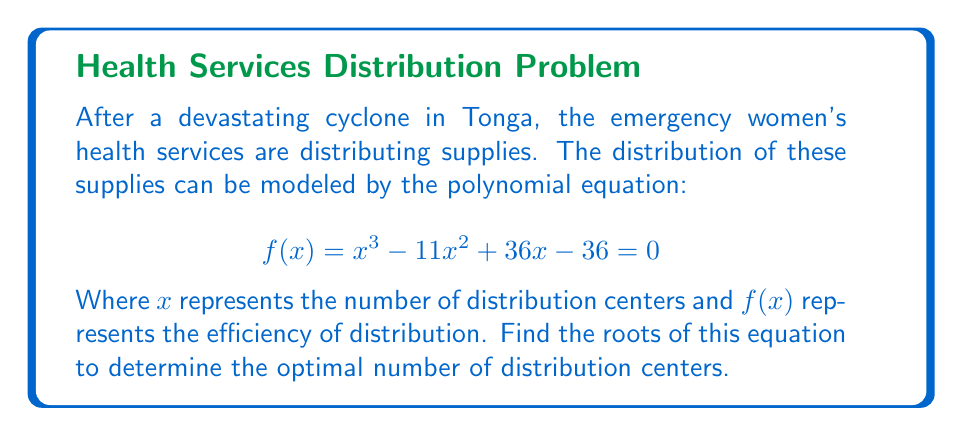Solve this math problem. To find the roots of the polynomial equation, we'll use the factor theorem and synthetic division:

1) First, let's guess a potential root. Since the constant term is -36, potential factors are ±1, ±2, ±3, ±4, ±6, ±9, ±12, ±18, ±36.

2) Let's try x = 3:
   
   $$3^3 - 11(3)^2 + 36(3) - 36 = 27 - 99 + 108 - 36 = 0$$

   So, 3 is a root.

3) Now, let's use synthetic division to factor out (x - 3):

   $$
   \begin{array}{r}
   3 | 1 \quad -11 \quad 36 \quad -36 \\
     | \quad 3 \quad -24 \quad 36 \\
   \hline
     1 \quad -8 \quad 12 \quad 0
   \end{array}
   $$

4) The polynomial can now be written as:
   
   $$(x - 3)(x^2 - 8x + 12) = 0$$

5) We can factor the quadratic term:
   
   $$(x - 3)(x - 6)(x - 2) = 0$$

6) Therefore, the roots are x = 3, x = 6, and x = 2.
Answer: The roots are 2, 3, and 6. 